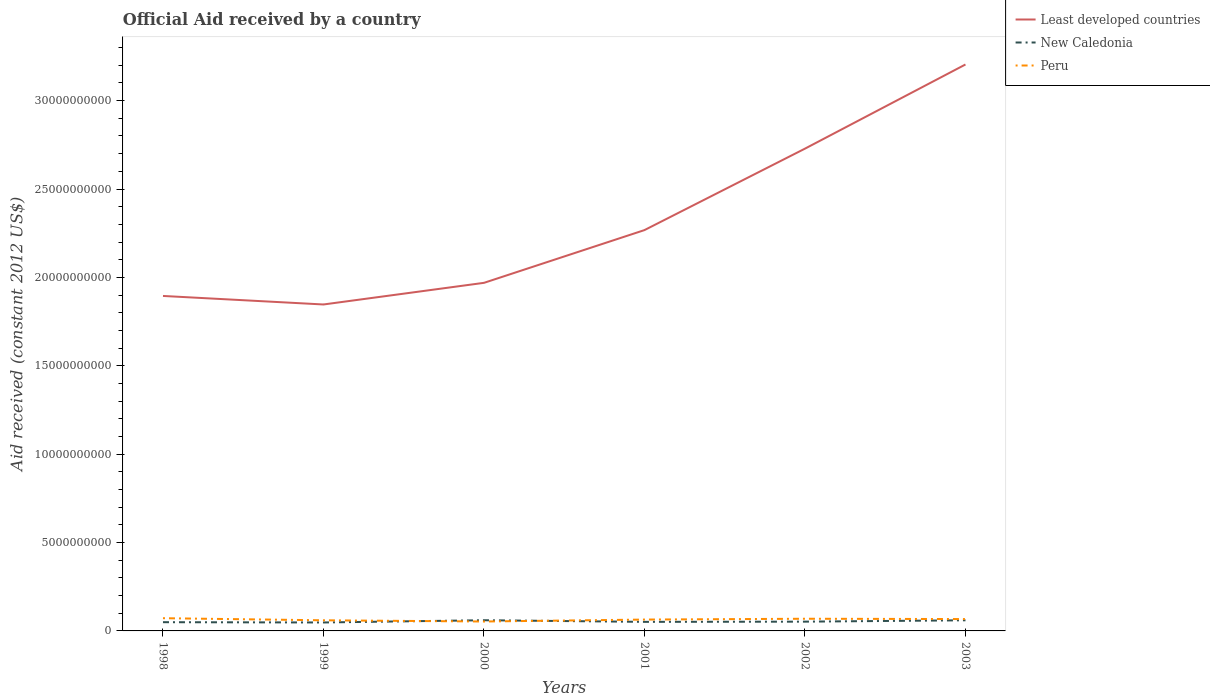Does the line corresponding to Least developed countries intersect with the line corresponding to New Caledonia?
Ensure brevity in your answer.  No. Across all years, what is the maximum net official aid received in New Caledonia?
Your response must be concise. 4.78e+08. In which year was the net official aid received in Peru maximum?
Ensure brevity in your answer.  2000. What is the total net official aid received in Least developed countries in the graph?
Ensure brevity in your answer.  -1.22e+09. What is the difference between the highest and the second highest net official aid received in Least developed countries?
Offer a terse response. 1.36e+1. What is the difference between the highest and the lowest net official aid received in Peru?
Offer a terse response. 3. Is the net official aid received in New Caledonia strictly greater than the net official aid received in Peru over the years?
Your response must be concise. No. How many years are there in the graph?
Provide a short and direct response. 6. Are the values on the major ticks of Y-axis written in scientific E-notation?
Offer a terse response. No. Does the graph contain grids?
Your answer should be compact. No. Where does the legend appear in the graph?
Your answer should be compact. Top right. How are the legend labels stacked?
Your answer should be very brief. Vertical. What is the title of the graph?
Keep it short and to the point. Official Aid received by a country. Does "Europe(all income levels)" appear as one of the legend labels in the graph?
Ensure brevity in your answer.  No. What is the label or title of the Y-axis?
Ensure brevity in your answer.  Aid received (constant 2012 US$). What is the Aid received (constant 2012 US$) of Least developed countries in 1998?
Offer a terse response. 1.89e+1. What is the Aid received (constant 2012 US$) of New Caledonia in 1998?
Your answer should be compact. 4.94e+08. What is the Aid received (constant 2012 US$) in Peru in 1998?
Your answer should be very brief. 7.20e+08. What is the Aid received (constant 2012 US$) of Least developed countries in 1999?
Offer a terse response. 1.85e+1. What is the Aid received (constant 2012 US$) of New Caledonia in 1999?
Provide a short and direct response. 4.78e+08. What is the Aid received (constant 2012 US$) of Peru in 1999?
Give a very brief answer. 6.01e+08. What is the Aid received (constant 2012 US$) in Least developed countries in 2000?
Provide a short and direct response. 1.97e+1. What is the Aid received (constant 2012 US$) of New Caledonia in 2000?
Make the answer very short. 6.05e+08. What is the Aid received (constant 2012 US$) of Peru in 2000?
Your response must be concise. 5.33e+08. What is the Aid received (constant 2012 US$) in Least developed countries in 2001?
Offer a very short reply. 2.27e+1. What is the Aid received (constant 2012 US$) of New Caledonia in 2001?
Your answer should be compact. 5.13e+08. What is the Aid received (constant 2012 US$) of Peru in 2001?
Your answer should be very brief. 6.42e+08. What is the Aid received (constant 2012 US$) of Least developed countries in 2002?
Your answer should be compact. 2.73e+1. What is the Aid received (constant 2012 US$) of New Caledonia in 2002?
Provide a short and direct response. 5.25e+08. What is the Aid received (constant 2012 US$) in Peru in 2002?
Your response must be concise. 6.89e+08. What is the Aid received (constant 2012 US$) in Least developed countries in 2003?
Keep it short and to the point. 3.20e+1. What is the Aid received (constant 2012 US$) in New Caledonia in 2003?
Keep it short and to the point. 6.01e+08. What is the Aid received (constant 2012 US$) in Peru in 2003?
Provide a succinct answer. 6.71e+08. Across all years, what is the maximum Aid received (constant 2012 US$) of Least developed countries?
Provide a succinct answer. 3.20e+1. Across all years, what is the maximum Aid received (constant 2012 US$) of New Caledonia?
Your answer should be compact. 6.05e+08. Across all years, what is the maximum Aid received (constant 2012 US$) in Peru?
Your answer should be very brief. 7.20e+08. Across all years, what is the minimum Aid received (constant 2012 US$) of Least developed countries?
Your answer should be very brief. 1.85e+1. Across all years, what is the minimum Aid received (constant 2012 US$) of New Caledonia?
Keep it short and to the point. 4.78e+08. Across all years, what is the minimum Aid received (constant 2012 US$) in Peru?
Give a very brief answer. 5.33e+08. What is the total Aid received (constant 2012 US$) of Least developed countries in the graph?
Ensure brevity in your answer.  1.39e+11. What is the total Aid received (constant 2012 US$) of New Caledonia in the graph?
Offer a very short reply. 3.22e+09. What is the total Aid received (constant 2012 US$) in Peru in the graph?
Keep it short and to the point. 3.86e+09. What is the difference between the Aid received (constant 2012 US$) in Least developed countries in 1998 and that in 1999?
Make the answer very short. 4.83e+08. What is the difference between the Aid received (constant 2012 US$) in New Caledonia in 1998 and that in 1999?
Ensure brevity in your answer.  1.58e+07. What is the difference between the Aid received (constant 2012 US$) of Peru in 1998 and that in 1999?
Offer a terse response. 1.18e+08. What is the difference between the Aid received (constant 2012 US$) of Least developed countries in 1998 and that in 2000?
Provide a short and direct response. -7.42e+08. What is the difference between the Aid received (constant 2012 US$) in New Caledonia in 1998 and that in 2000?
Offer a very short reply. -1.11e+08. What is the difference between the Aid received (constant 2012 US$) of Peru in 1998 and that in 2000?
Keep it short and to the point. 1.87e+08. What is the difference between the Aid received (constant 2012 US$) of Least developed countries in 1998 and that in 2001?
Give a very brief answer. -3.73e+09. What is the difference between the Aid received (constant 2012 US$) in New Caledonia in 1998 and that in 2001?
Provide a succinct answer. -1.86e+07. What is the difference between the Aid received (constant 2012 US$) in Peru in 1998 and that in 2001?
Keep it short and to the point. 7.73e+07. What is the difference between the Aid received (constant 2012 US$) of Least developed countries in 1998 and that in 2002?
Ensure brevity in your answer.  -8.33e+09. What is the difference between the Aid received (constant 2012 US$) of New Caledonia in 1998 and that in 2002?
Your response must be concise. -3.07e+07. What is the difference between the Aid received (constant 2012 US$) of Peru in 1998 and that in 2002?
Make the answer very short. 3.09e+07. What is the difference between the Aid received (constant 2012 US$) in Least developed countries in 1998 and that in 2003?
Offer a terse response. -1.31e+1. What is the difference between the Aid received (constant 2012 US$) of New Caledonia in 1998 and that in 2003?
Ensure brevity in your answer.  -1.07e+08. What is the difference between the Aid received (constant 2012 US$) in Peru in 1998 and that in 2003?
Make the answer very short. 4.85e+07. What is the difference between the Aid received (constant 2012 US$) in Least developed countries in 1999 and that in 2000?
Ensure brevity in your answer.  -1.22e+09. What is the difference between the Aid received (constant 2012 US$) in New Caledonia in 1999 and that in 2000?
Your answer should be very brief. -1.27e+08. What is the difference between the Aid received (constant 2012 US$) in Peru in 1999 and that in 2000?
Give a very brief answer. 6.85e+07. What is the difference between the Aid received (constant 2012 US$) of Least developed countries in 1999 and that in 2001?
Provide a succinct answer. -4.21e+09. What is the difference between the Aid received (constant 2012 US$) in New Caledonia in 1999 and that in 2001?
Keep it short and to the point. -3.45e+07. What is the difference between the Aid received (constant 2012 US$) of Peru in 1999 and that in 2001?
Your response must be concise. -4.11e+07. What is the difference between the Aid received (constant 2012 US$) in Least developed countries in 1999 and that in 2002?
Offer a very short reply. -8.82e+09. What is the difference between the Aid received (constant 2012 US$) of New Caledonia in 1999 and that in 2002?
Provide a succinct answer. -4.66e+07. What is the difference between the Aid received (constant 2012 US$) of Peru in 1999 and that in 2002?
Give a very brief answer. -8.75e+07. What is the difference between the Aid received (constant 2012 US$) of Least developed countries in 1999 and that in 2003?
Ensure brevity in your answer.  -1.36e+1. What is the difference between the Aid received (constant 2012 US$) of New Caledonia in 1999 and that in 2003?
Your answer should be very brief. -1.23e+08. What is the difference between the Aid received (constant 2012 US$) of Peru in 1999 and that in 2003?
Provide a short and direct response. -7.00e+07. What is the difference between the Aid received (constant 2012 US$) of Least developed countries in 2000 and that in 2001?
Provide a succinct answer. -2.98e+09. What is the difference between the Aid received (constant 2012 US$) of New Caledonia in 2000 and that in 2001?
Give a very brief answer. 9.23e+07. What is the difference between the Aid received (constant 2012 US$) of Peru in 2000 and that in 2001?
Offer a terse response. -1.10e+08. What is the difference between the Aid received (constant 2012 US$) in Least developed countries in 2000 and that in 2002?
Your answer should be very brief. -7.59e+09. What is the difference between the Aid received (constant 2012 US$) of New Caledonia in 2000 and that in 2002?
Offer a terse response. 8.02e+07. What is the difference between the Aid received (constant 2012 US$) of Peru in 2000 and that in 2002?
Make the answer very short. -1.56e+08. What is the difference between the Aid received (constant 2012 US$) in Least developed countries in 2000 and that in 2003?
Ensure brevity in your answer.  -1.24e+1. What is the difference between the Aid received (constant 2012 US$) of New Caledonia in 2000 and that in 2003?
Provide a short and direct response. 3.50e+06. What is the difference between the Aid received (constant 2012 US$) in Peru in 2000 and that in 2003?
Give a very brief answer. -1.38e+08. What is the difference between the Aid received (constant 2012 US$) in Least developed countries in 2001 and that in 2002?
Offer a very short reply. -4.61e+09. What is the difference between the Aid received (constant 2012 US$) of New Caledonia in 2001 and that in 2002?
Provide a short and direct response. -1.21e+07. What is the difference between the Aid received (constant 2012 US$) of Peru in 2001 and that in 2002?
Provide a short and direct response. -4.64e+07. What is the difference between the Aid received (constant 2012 US$) in Least developed countries in 2001 and that in 2003?
Give a very brief answer. -9.37e+09. What is the difference between the Aid received (constant 2012 US$) in New Caledonia in 2001 and that in 2003?
Your answer should be very brief. -8.88e+07. What is the difference between the Aid received (constant 2012 US$) in Peru in 2001 and that in 2003?
Keep it short and to the point. -2.88e+07. What is the difference between the Aid received (constant 2012 US$) of Least developed countries in 2002 and that in 2003?
Give a very brief answer. -4.76e+09. What is the difference between the Aid received (constant 2012 US$) in New Caledonia in 2002 and that in 2003?
Offer a very short reply. -7.67e+07. What is the difference between the Aid received (constant 2012 US$) in Peru in 2002 and that in 2003?
Make the answer very short. 1.76e+07. What is the difference between the Aid received (constant 2012 US$) of Least developed countries in 1998 and the Aid received (constant 2012 US$) of New Caledonia in 1999?
Offer a very short reply. 1.85e+1. What is the difference between the Aid received (constant 2012 US$) of Least developed countries in 1998 and the Aid received (constant 2012 US$) of Peru in 1999?
Ensure brevity in your answer.  1.83e+1. What is the difference between the Aid received (constant 2012 US$) in New Caledonia in 1998 and the Aid received (constant 2012 US$) in Peru in 1999?
Offer a very short reply. -1.07e+08. What is the difference between the Aid received (constant 2012 US$) of Least developed countries in 1998 and the Aid received (constant 2012 US$) of New Caledonia in 2000?
Your response must be concise. 1.83e+1. What is the difference between the Aid received (constant 2012 US$) of Least developed countries in 1998 and the Aid received (constant 2012 US$) of Peru in 2000?
Provide a short and direct response. 1.84e+1. What is the difference between the Aid received (constant 2012 US$) in New Caledonia in 1998 and the Aid received (constant 2012 US$) in Peru in 2000?
Keep it short and to the point. -3.87e+07. What is the difference between the Aid received (constant 2012 US$) of Least developed countries in 1998 and the Aid received (constant 2012 US$) of New Caledonia in 2001?
Your response must be concise. 1.84e+1. What is the difference between the Aid received (constant 2012 US$) in Least developed countries in 1998 and the Aid received (constant 2012 US$) in Peru in 2001?
Your response must be concise. 1.83e+1. What is the difference between the Aid received (constant 2012 US$) in New Caledonia in 1998 and the Aid received (constant 2012 US$) in Peru in 2001?
Your answer should be very brief. -1.48e+08. What is the difference between the Aid received (constant 2012 US$) of Least developed countries in 1998 and the Aid received (constant 2012 US$) of New Caledonia in 2002?
Offer a terse response. 1.84e+1. What is the difference between the Aid received (constant 2012 US$) in Least developed countries in 1998 and the Aid received (constant 2012 US$) in Peru in 2002?
Give a very brief answer. 1.83e+1. What is the difference between the Aid received (constant 2012 US$) in New Caledonia in 1998 and the Aid received (constant 2012 US$) in Peru in 2002?
Offer a very short reply. -1.95e+08. What is the difference between the Aid received (constant 2012 US$) in Least developed countries in 1998 and the Aid received (constant 2012 US$) in New Caledonia in 2003?
Provide a succinct answer. 1.83e+1. What is the difference between the Aid received (constant 2012 US$) of Least developed countries in 1998 and the Aid received (constant 2012 US$) of Peru in 2003?
Make the answer very short. 1.83e+1. What is the difference between the Aid received (constant 2012 US$) in New Caledonia in 1998 and the Aid received (constant 2012 US$) in Peru in 2003?
Your answer should be very brief. -1.77e+08. What is the difference between the Aid received (constant 2012 US$) of Least developed countries in 1999 and the Aid received (constant 2012 US$) of New Caledonia in 2000?
Keep it short and to the point. 1.79e+1. What is the difference between the Aid received (constant 2012 US$) in Least developed countries in 1999 and the Aid received (constant 2012 US$) in Peru in 2000?
Make the answer very short. 1.79e+1. What is the difference between the Aid received (constant 2012 US$) of New Caledonia in 1999 and the Aid received (constant 2012 US$) of Peru in 2000?
Your answer should be very brief. -5.46e+07. What is the difference between the Aid received (constant 2012 US$) in Least developed countries in 1999 and the Aid received (constant 2012 US$) in New Caledonia in 2001?
Make the answer very short. 1.80e+1. What is the difference between the Aid received (constant 2012 US$) of Least developed countries in 1999 and the Aid received (constant 2012 US$) of Peru in 2001?
Offer a very short reply. 1.78e+1. What is the difference between the Aid received (constant 2012 US$) of New Caledonia in 1999 and the Aid received (constant 2012 US$) of Peru in 2001?
Your answer should be very brief. -1.64e+08. What is the difference between the Aid received (constant 2012 US$) in Least developed countries in 1999 and the Aid received (constant 2012 US$) in New Caledonia in 2002?
Your answer should be very brief. 1.79e+1. What is the difference between the Aid received (constant 2012 US$) in Least developed countries in 1999 and the Aid received (constant 2012 US$) in Peru in 2002?
Your response must be concise. 1.78e+1. What is the difference between the Aid received (constant 2012 US$) of New Caledonia in 1999 and the Aid received (constant 2012 US$) of Peru in 2002?
Your answer should be compact. -2.11e+08. What is the difference between the Aid received (constant 2012 US$) in Least developed countries in 1999 and the Aid received (constant 2012 US$) in New Caledonia in 2003?
Your answer should be compact. 1.79e+1. What is the difference between the Aid received (constant 2012 US$) of Least developed countries in 1999 and the Aid received (constant 2012 US$) of Peru in 2003?
Ensure brevity in your answer.  1.78e+1. What is the difference between the Aid received (constant 2012 US$) in New Caledonia in 1999 and the Aid received (constant 2012 US$) in Peru in 2003?
Offer a very short reply. -1.93e+08. What is the difference between the Aid received (constant 2012 US$) in Least developed countries in 2000 and the Aid received (constant 2012 US$) in New Caledonia in 2001?
Provide a succinct answer. 1.92e+1. What is the difference between the Aid received (constant 2012 US$) of Least developed countries in 2000 and the Aid received (constant 2012 US$) of Peru in 2001?
Provide a short and direct response. 1.90e+1. What is the difference between the Aid received (constant 2012 US$) of New Caledonia in 2000 and the Aid received (constant 2012 US$) of Peru in 2001?
Provide a succinct answer. -3.74e+07. What is the difference between the Aid received (constant 2012 US$) in Least developed countries in 2000 and the Aid received (constant 2012 US$) in New Caledonia in 2002?
Your response must be concise. 1.92e+1. What is the difference between the Aid received (constant 2012 US$) of Least developed countries in 2000 and the Aid received (constant 2012 US$) of Peru in 2002?
Ensure brevity in your answer.  1.90e+1. What is the difference between the Aid received (constant 2012 US$) in New Caledonia in 2000 and the Aid received (constant 2012 US$) in Peru in 2002?
Your response must be concise. -8.38e+07. What is the difference between the Aid received (constant 2012 US$) in Least developed countries in 2000 and the Aid received (constant 2012 US$) in New Caledonia in 2003?
Provide a succinct answer. 1.91e+1. What is the difference between the Aid received (constant 2012 US$) in Least developed countries in 2000 and the Aid received (constant 2012 US$) in Peru in 2003?
Provide a short and direct response. 1.90e+1. What is the difference between the Aid received (constant 2012 US$) in New Caledonia in 2000 and the Aid received (constant 2012 US$) in Peru in 2003?
Your response must be concise. -6.62e+07. What is the difference between the Aid received (constant 2012 US$) of Least developed countries in 2001 and the Aid received (constant 2012 US$) of New Caledonia in 2002?
Ensure brevity in your answer.  2.22e+1. What is the difference between the Aid received (constant 2012 US$) in Least developed countries in 2001 and the Aid received (constant 2012 US$) in Peru in 2002?
Keep it short and to the point. 2.20e+1. What is the difference between the Aid received (constant 2012 US$) in New Caledonia in 2001 and the Aid received (constant 2012 US$) in Peru in 2002?
Provide a succinct answer. -1.76e+08. What is the difference between the Aid received (constant 2012 US$) of Least developed countries in 2001 and the Aid received (constant 2012 US$) of New Caledonia in 2003?
Keep it short and to the point. 2.21e+1. What is the difference between the Aid received (constant 2012 US$) in Least developed countries in 2001 and the Aid received (constant 2012 US$) in Peru in 2003?
Provide a succinct answer. 2.20e+1. What is the difference between the Aid received (constant 2012 US$) of New Caledonia in 2001 and the Aid received (constant 2012 US$) of Peru in 2003?
Offer a terse response. -1.59e+08. What is the difference between the Aid received (constant 2012 US$) in Least developed countries in 2002 and the Aid received (constant 2012 US$) in New Caledonia in 2003?
Give a very brief answer. 2.67e+1. What is the difference between the Aid received (constant 2012 US$) in Least developed countries in 2002 and the Aid received (constant 2012 US$) in Peru in 2003?
Ensure brevity in your answer.  2.66e+1. What is the difference between the Aid received (constant 2012 US$) of New Caledonia in 2002 and the Aid received (constant 2012 US$) of Peru in 2003?
Provide a succinct answer. -1.46e+08. What is the average Aid received (constant 2012 US$) in Least developed countries per year?
Give a very brief answer. 2.32e+1. What is the average Aid received (constant 2012 US$) in New Caledonia per year?
Your answer should be very brief. 5.36e+08. What is the average Aid received (constant 2012 US$) of Peru per year?
Offer a terse response. 6.43e+08. In the year 1998, what is the difference between the Aid received (constant 2012 US$) of Least developed countries and Aid received (constant 2012 US$) of New Caledonia?
Provide a succinct answer. 1.85e+1. In the year 1998, what is the difference between the Aid received (constant 2012 US$) of Least developed countries and Aid received (constant 2012 US$) of Peru?
Your response must be concise. 1.82e+1. In the year 1998, what is the difference between the Aid received (constant 2012 US$) of New Caledonia and Aid received (constant 2012 US$) of Peru?
Make the answer very short. -2.26e+08. In the year 1999, what is the difference between the Aid received (constant 2012 US$) in Least developed countries and Aid received (constant 2012 US$) in New Caledonia?
Offer a terse response. 1.80e+1. In the year 1999, what is the difference between the Aid received (constant 2012 US$) in Least developed countries and Aid received (constant 2012 US$) in Peru?
Provide a succinct answer. 1.79e+1. In the year 1999, what is the difference between the Aid received (constant 2012 US$) of New Caledonia and Aid received (constant 2012 US$) of Peru?
Provide a succinct answer. -1.23e+08. In the year 2000, what is the difference between the Aid received (constant 2012 US$) in Least developed countries and Aid received (constant 2012 US$) in New Caledonia?
Your response must be concise. 1.91e+1. In the year 2000, what is the difference between the Aid received (constant 2012 US$) in Least developed countries and Aid received (constant 2012 US$) in Peru?
Offer a very short reply. 1.92e+1. In the year 2000, what is the difference between the Aid received (constant 2012 US$) of New Caledonia and Aid received (constant 2012 US$) of Peru?
Keep it short and to the point. 7.22e+07. In the year 2001, what is the difference between the Aid received (constant 2012 US$) of Least developed countries and Aid received (constant 2012 US$) of New Caledonia?
Ensure brevity in your answer.  2.22e+1. In the year 2001, what is the difference between the Aid received (constant 2012 US$) of Least developed countries and Aid received (constant 2012 US$) of Peru?
Your answer should be very brief. 2.20e+1. In the year 2001, what is the difference between the Aid received (constant 2012 US$) in New Caledonia and Aid received (constant 2012 US$) in Peru?
Your response must be concise. -1.30e+08. In the year 2002, what is the difference between the Aid received (constant 2012 US$) of Least developed countries and Aid received (constant 2012 US$) of New Caledonia?
Provide a short and direct response. 2.68e+1. In the year 2002, what is the difference between the Aid received (constant 2012 US$) of Least developed countries and Aid received (constant 2012 US$) of Peru?
Ensure brevity in your answer.  2.66e+1. In the year 2002, what is the difference between the Aid received (constant 2012 US$) in New Caledonia and Aid received (constant 2012 US$) in Peru?
Offer a terse response. -1.64e+08. In the year 2003, what is the difference between the Aid received (constant 2012 US$) of Least developed countries and Aid received (constant 2012 US$) of New Caledonia?
Ensure brevity in your answer.  3.14e+1. In the year 2003, what is the difference between the Aid received (constant 2012 US$) in Least developed countries and Aid received (constant 2012 US$) in Peru?
Your answer should be very brief. 3.14e+1. In the year 2003, what is the difference between the Aid received (constant 2012 US$) in New Caledonia and Aid received (constant 2012 US$) in Peru?
Make the answer very short. -6.97e+07. What is the ratio of the Aid received (constant 2012 US$) in Least developed countries in 1998 to that in 1999?
Your answer should be very brief. 1.03. What is the ratio of the Aid received (constant 2012 US$) of New Caledonia in 1998 to that in 1999?
Keep it short and to the point. 1.03. What is the ratio of the Aid received (constant 2012 US$) in Peru in 1998 to that in 1999?
Provide a short and direct response. 1.2. What is the ratio of the Aid received (constant 2012 US$) of Least developed countries in 1998 to that in 2000?
Offer a very short reply. 0.96. What is the ratio of the Aid received (constant 2012 US$) of New Caledonia in 1998 to that in 2000?
Your response must be concise. 0.82. What is the ratio of the Aid received (constant 2012 US$) in Peru in 1998 to that in 2000?
Make the answer very short. 1.35. What is the ratio of the Aid received (constant 2012 US$) in Least developed countries in 1998 to that in 2001?
Keep it short and to the point. 0.84. What is the ratio of the Aid received (constant 2012 US$) in New Caledonia in 1998 to that in 2001?
Make the answer very short. 0.96. What is the ratio of the Aid received (constant 2012 US$) in Peru in 1998 to that in 2001?
Make the answer very short. 1.12. What is the ratio of the Aid received (constant 2012 US$) of Least developed countries in 1998 to that in 2002?
Your answer should be compact. 0.69. What is the ratio of the Aid received (constant 2012 US$) in New Caledonia in 1998 to that in 2002?
Make the answer very short. 0.94. What is the ratio of the Aid received (constant 2012 US$) in Peru in 1998 to that in 2002?
Make the answer very short. 1.04. What is the ratio of the Aid received (constant 2012 US$) in Least developed countries in 1998 to that in 2003?
Keep it short and to the point. 0.59. What is the ratio of the Aid received (constant 2012 US$) of New Caledonia in 1998 to that in 2003?
Make the answer very short. 0.82. What is the ratio of the Aid received (constant 2012 US$) of Peru in 1998 to that in 2003?
Make the answer very short. 1.07. What is the ratio of the Aid received (constant 2012 US$) of Least developed countries in 1999 to that in 2000?
Ensure brevity in your answer.  0.94. What is the ratio of the Aid received (constant 2012 US$) in New Caledonia in 1999 to that in 2000?
Offer a terse response. 0.79. What is the ratio of the Aid received (constant 2012 US$) of Peru in 1999 to that in 2000?
Your answer should be very brief. 1.13. What is the ratio of the Aid received (constant 2012 US$) of Least developed countries in 1999 to that in 2001?
Offer a terse response. 0.81. What is the ratio of the Aid received (constant 2012 US$) of New Caledonia in 1999 to that in 2001?
Offer a terse response. 0.93. What is the ratio of the Aid received (constant 2012 US$) of Peru in 1999 to that in 2001?
Your response must be concise. 0.94. What is the ratio of the Aid received (constant 2012 US$) of Least developed countries in 1999 to that in 2002?
Your response must be concise. 0.68. What is the ratio of the Aid received (constant 2012 US$) in New Caledonia in 1999 to that in 2002?
Provide a short and direct response. 0.91. What is the ratio of the Aid received (constant 2012 US$) of Peru in 1999 to that in 2002?
Offer a very short reply. 0.87. What is the ratio of the Aid received (constant 2012 US$) of Least developed countries in 1999 to that in 2003?
Provide a short and direct response. 0.58. What is the ratio of the Aid received (constant 2012 US$) of New Caledonia in 1999 to that in 2003?
Provide a succinct answer. 0.8. What is the ratio of the Aid received (constant 2012 US$) of Peru in 1999 to that in 2003?
Provide a short and direct response. 0.9. What is the ratio of the Aid received (constant 2012 US$) in Least developed countries in 2000 to that in 2001?
Provide a short and direct response. 0.87. What is the ratio of the Aid received (constant 2012 US$) of New Caledonia in 2000 to that in 2001?
Provide a succinct answer. 1.18. What is the ratio of the Aid received (constant 2012 US$) in Peru in 2000 to that in 2001?
Your answer should be very brief. 0.83. What is the ratio of the Aid received (constant 2012 US$) in Least developed countries in 2000 to that in 2002?
Your answer should be very brief. 0.72. What is the ratio of the Aid received (constant 2012 US$) in New Caledonia in 2000 to that in 2002?
Make the answer very short. 1.15. What is the ratio of the Aid received (constant 2012 US$) of Peru in 2000 to that in 2002?
Provide a succinct answer. 0.77. What is the ratio of the Aid received (constant 2012 US$) in Least developed countries in 2000 to that in 2003?
Offer a very short reply. 0.61. What is the ratio of the Aid received (constant 2012 US$) of Peru in 2000 to that in 2003?
Provide a short and direct response. 0.79. What is the ratio of the Aid received (constant 2012 US$) of Least developed countries in 2001 to that in 2002?
Give a very brief answer. 0.83. What is the ratio of the Aid received (constant 2012 US$) of New Caledonia in 2001 to that in 2002?
Give a very brief answer. 0.98. What is the ratio of the Aid received (constant 2012 US$) of Peru in 2001 to that in 2002?
Your answer should be very brief. 0.93. What is the ratio of the Aid received (constant 2012 US$) in Least developed countries in 2001 to that in 2003?
Your answer should be compact. 0.71. What is the ratio of the Aid received (constant 2012 US$) in New Caledonia in 2001 to that in 2003?
Give a very brief answer. 0.85. What is the ratio of the Aid received (constant 2012 US$) in Least developed countries in 2002 to that in 2003?
Your response must be concise. 0.85. What is the ratio of the Aid received (constant 2012 US$) in New Caledonia in 2002 to that in 2003?
Keep it short and to the point. 0.87. What is the ratio of the Aid received (constant 2012 US$) of Peru in 2002 to that in 2003?
Your answer should be compact. 1.03. What is the difference between the highest and the second highest Aid received (constant 2012 US$) in Least developed countries?
Your answer should be very brief. 4.76e+09. What is the difference between the highest and the second highest Aid received (constant 2012 US$) in New Caledonia?
Offer a terse response. 3.50e+06. What is the difference between the highest and the second highest Aid received (constant 2012 US$) in Peru?
Make the answer very short. 3.09e+07. What is the difference between the highest and the lowest Aid received (constant 2012 US$) of Least developed countries?
Offer a terse response. 1.36e+1. What is the difference between the highest and the lowest Aid received (constant 2012 US$) of New Caledonia?
Offer a terse response. 1.27e+08. What is the difference between the highest and the lowest Aid received (constant 2012 US$) in Peru?
Provide a short and direct response. 1.87e+08. 